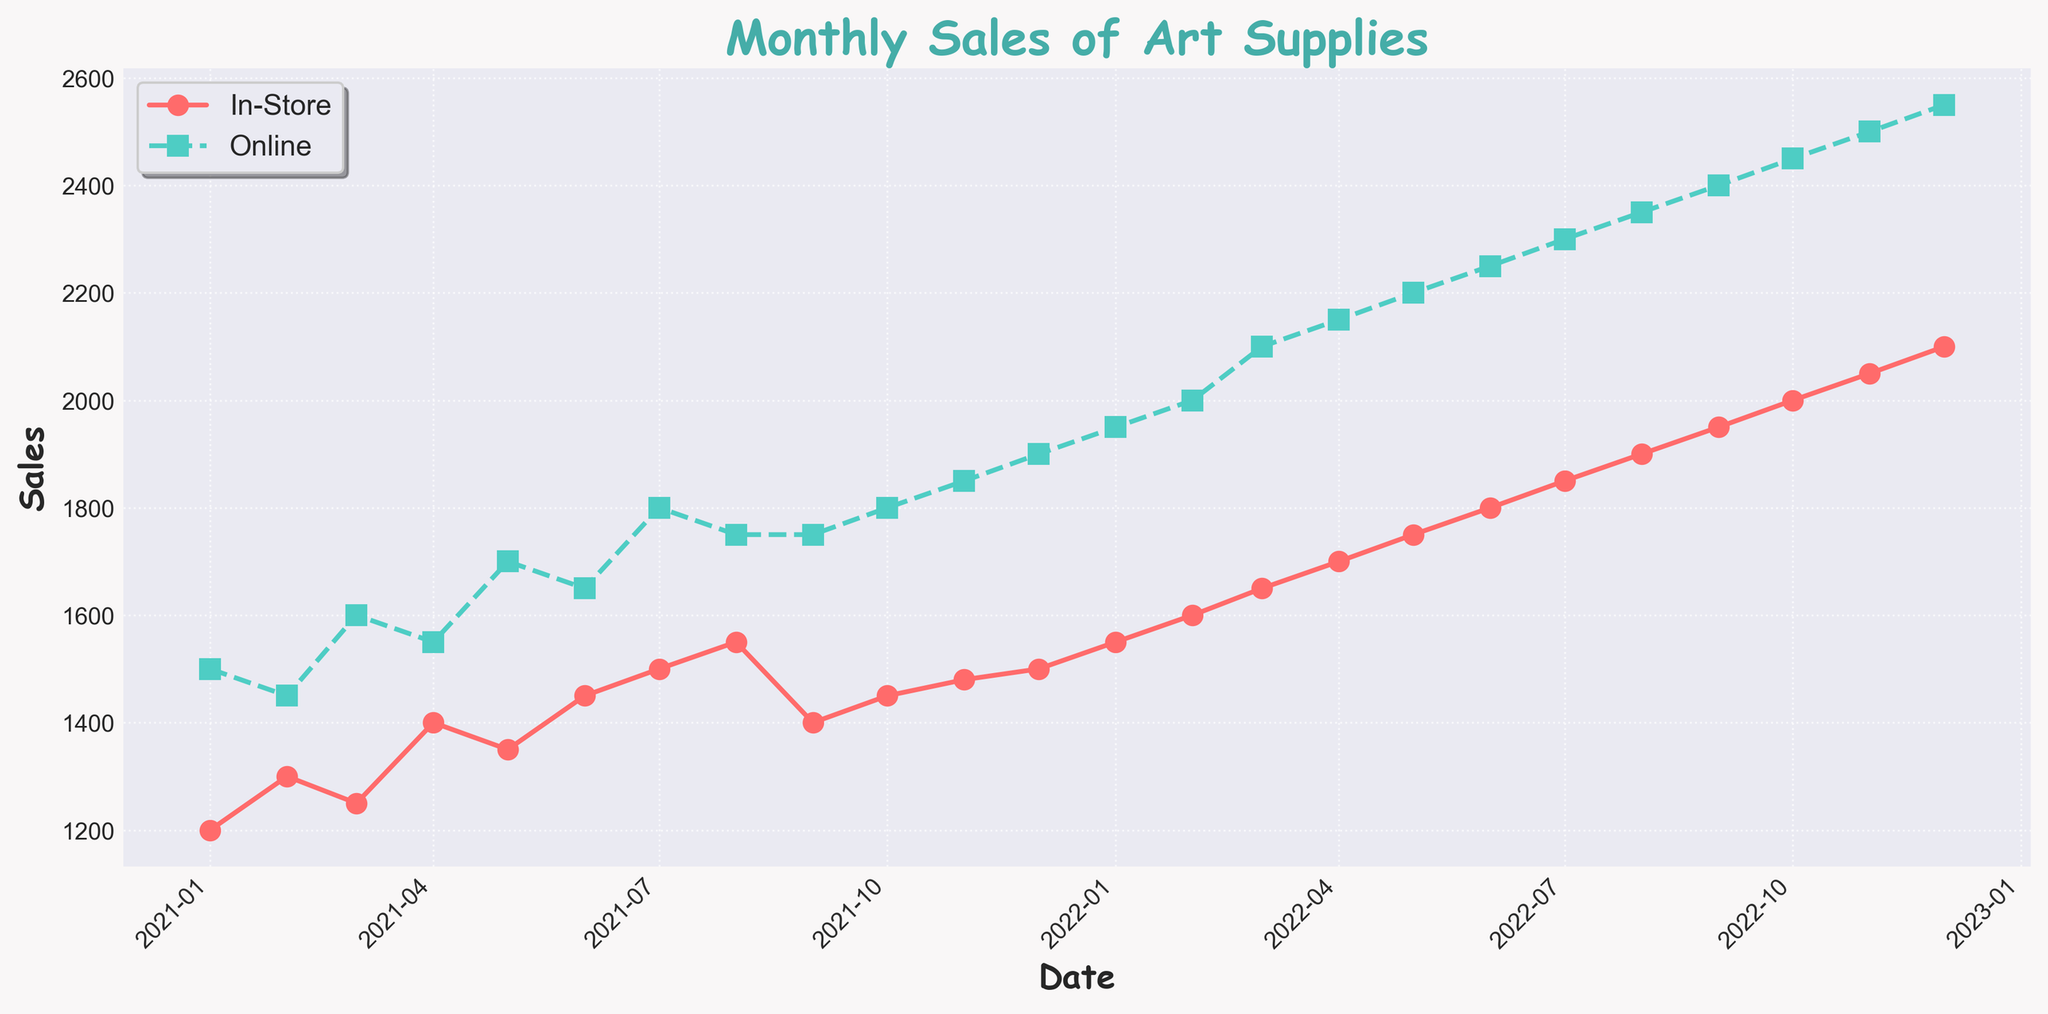What is the title of the plot? The title is displayed on top of the figure in bold and large font. Here, it reads 'Monthly Sales of Art Supplies'.
Answer: Monthly Sales of Art Supplies Which month had the highest in-store sales in 2021? Check the plot for 2021 and identify the month where the in-store sales line (red, solid) reaches its highest point. For 2021, the highest is in December.
Answer: December 2021 What are the colors used for in-store and online sales lines? The in-store sales line is in red, and the online sales line is in turquoise.
Answer: Red and Turquoise How many data points are plotted for each line in the figure? The figure spans from January 2021 to December 2022, with one data point per month. This results in 24 data points for each line.
Answer: 24 What is the trend of online sales from January 2021 to December 2022? The online sales line shows an increasing or rising trend from January 2021 to December 2022. This consistent upward movement indicates growth over the two-year period.
Answer: Increasing/Rising trend Which year shows the crossover point where online sales surpassed in-store sales? Identify the crossover by checking where the turquoise dashed line goes above the red solid line. The first noticeable crossover occurs around January 2021.
Answer: 2021 Compare the sales of in-store and online sales in June 2021. Which one is higher? Look at the June 2021 data points for both lines. The online sales (turquoise, dashed) are greater than in-store sales (red, solid) in this month.
Answer: Online Is there a month in 2022 where in-store sales decreased compared to the previous month? Carefully analyze the in-store sales line (red, solid) for any downward movement from one month to the next in 2022. In 2022, the in-store sales line never decreases from one month to the next.
Answer: No How many months did it take for online sales to reach 2500 from the start date? Online sales started at 1500 in January 2021. To determine when it reached 2500, track the turquoise dashed line until it hits 2500 in November 2022. So, it took 23 months.
Answer: 23 months 